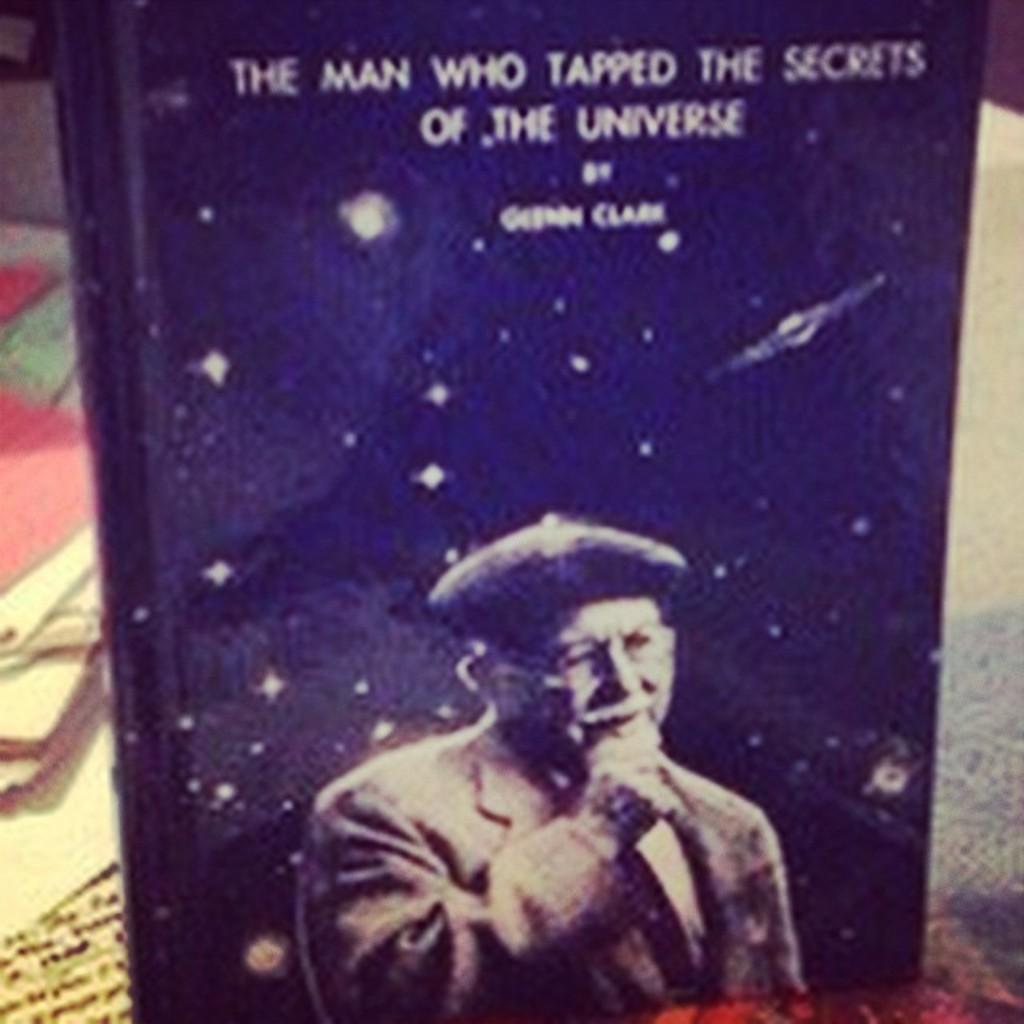Who "tapped the secrets of the universe"?
Offer a terse response. The man. What did the author do?
Your answer should be very brief. Tapped the secrets of the universe. 